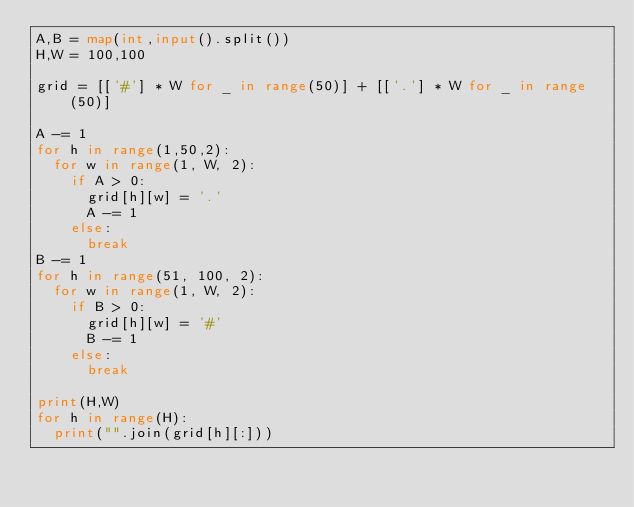<code> <loc_0><loc_0><loc_500><loc_500><_Python_>A,B = map(int,input().split())
H,W = 100,100

grid = [['#'] * W for _ in range(50)] + [['.'] * W for _ in range(50)]

A -= 1
for h in range(1,50,2):
	for w in range(1, W, 2):
		if A > 0:
			grid[h][w] = '.'
			A -= 1
		else:
			break
B -= 1
for h in range(51, 100, 2):
	for w in range(1, W, 2):
		if B > 0:
			grid[h][w] = '#'
			B -= 1
		else:
			break

print(H,W)
for h in range(H):
	print("".join(grid[h][:]))</code> 